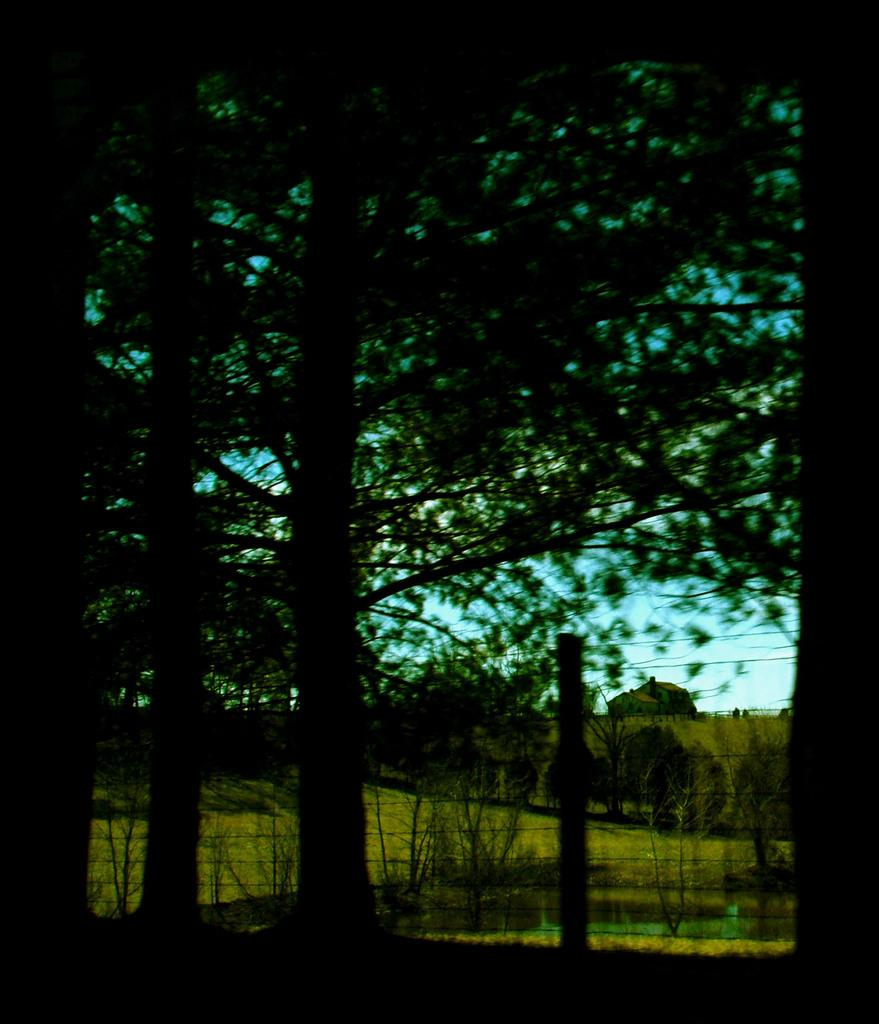What type of landscape is depicted in the image? There is a grassland in the image. What can be seen growing on the grassland? There are many trees on the grassland. What type of vest can be seen hanging on one of the trees in the image? There is no vest present in the image; it only features a grassland with many trees. 